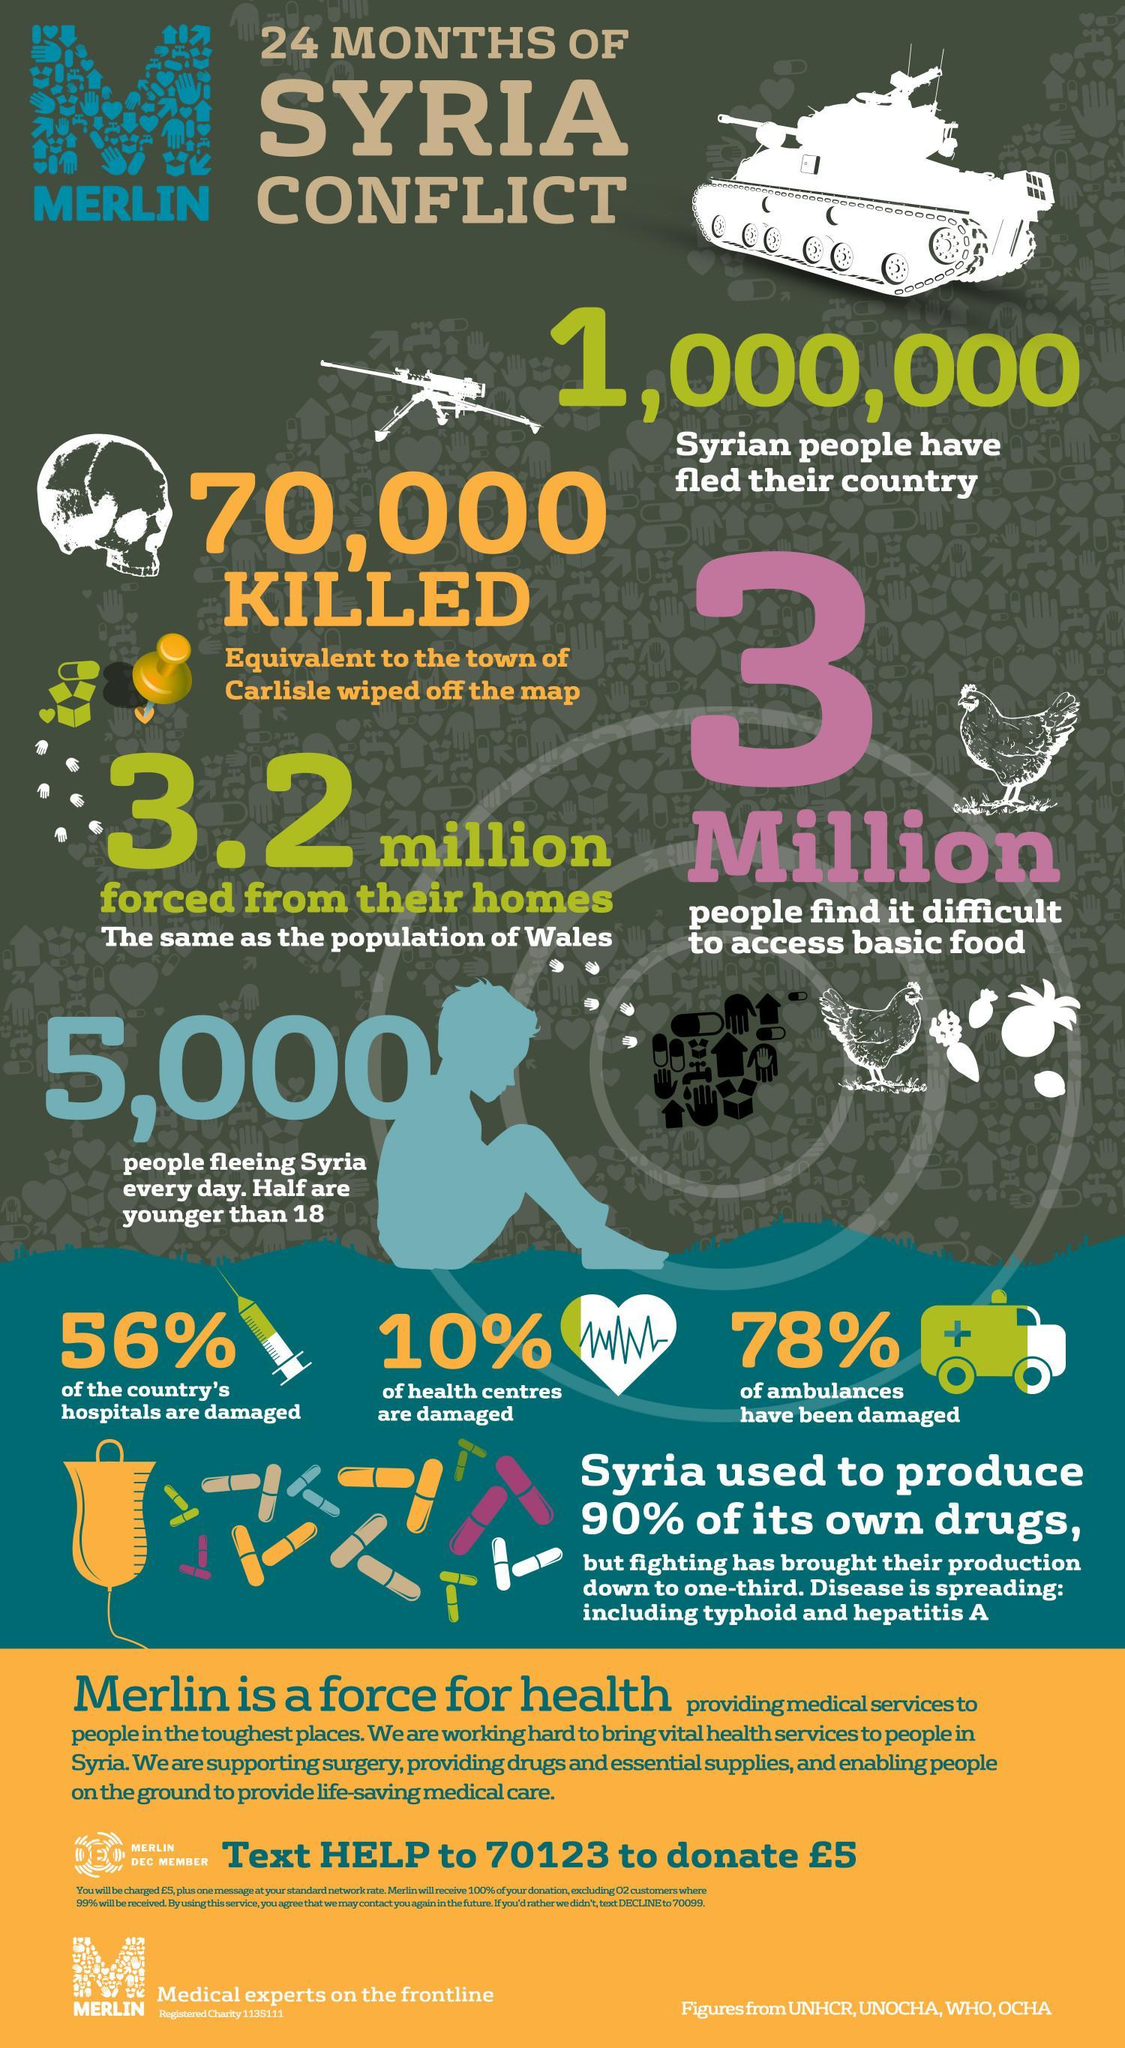What percent of the country's hospitals were not damaged in the Syrian Conflict?
Answer the question with a short phrase. 44% How many Syrians left their country due to the conflict? 1,000,000 What percent of people find it difficult to access basic food during the Syrian conflict? 3 Million How many Syrians died in the 24 months of Conflict? 70,000 What percent of the country's health centres were not damaged in the Syrian Conflict? 90% 